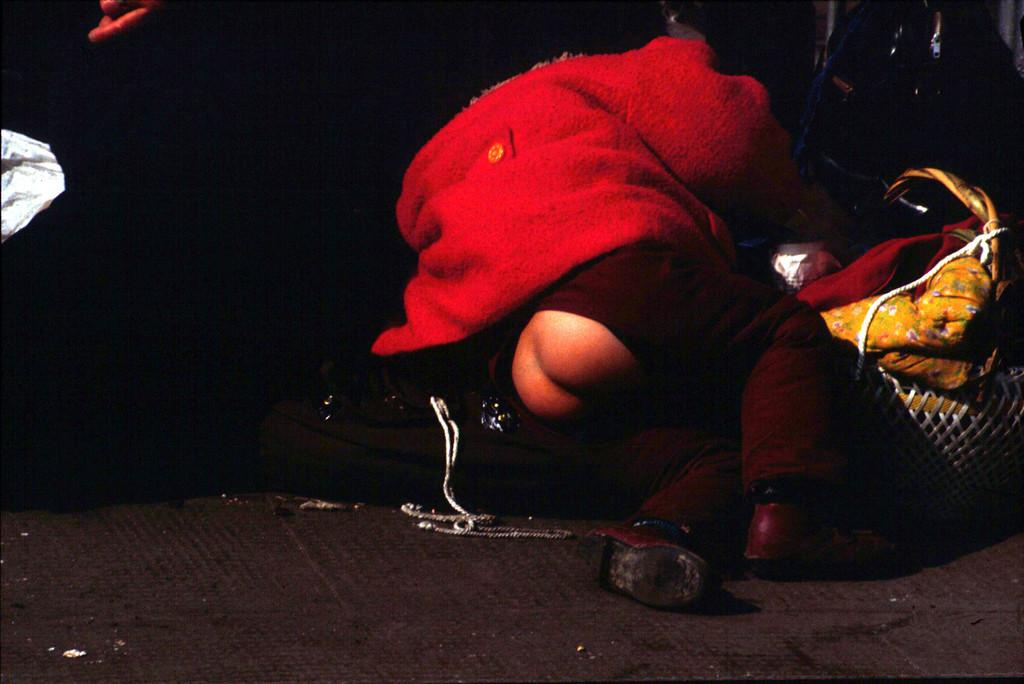Who or what is the main subject in the center of the image? There is a person in the center of the image. What can be seen in the background of the image? There are objects in the background of the image. What is at the bottom of the image? There is a walkway at the bottom of the image. How does the person in the image express regret? There is no indication of regret in the image, as it only shows a person in the center, objects in the background, and a walkway at the bottom. 